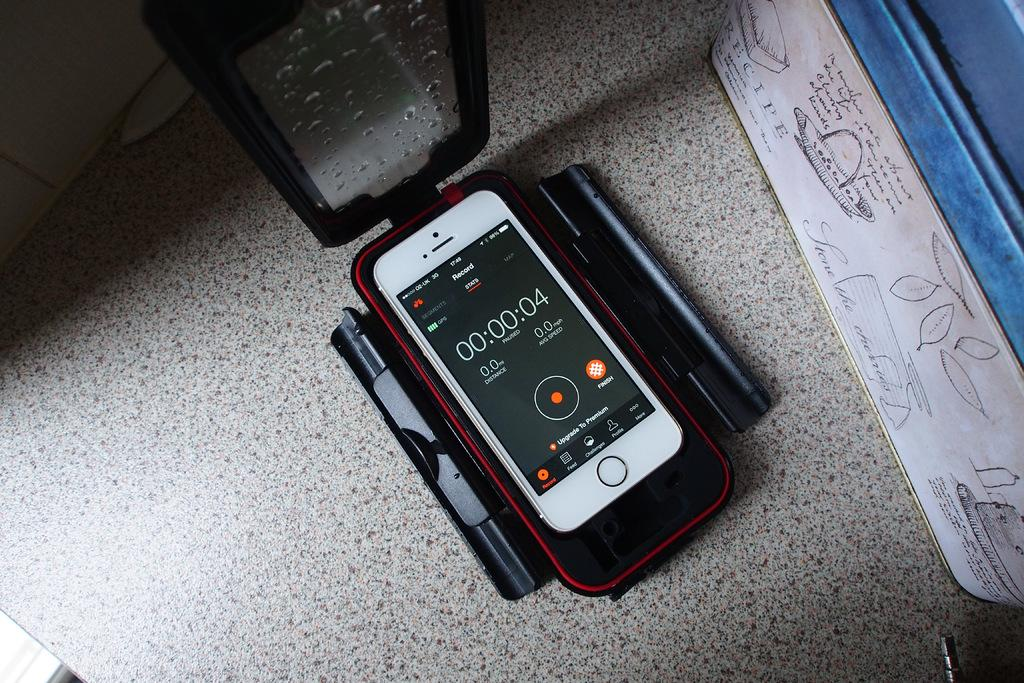<image>
Summarize the visual content of the image. the number 4 can be seen on the black screen 